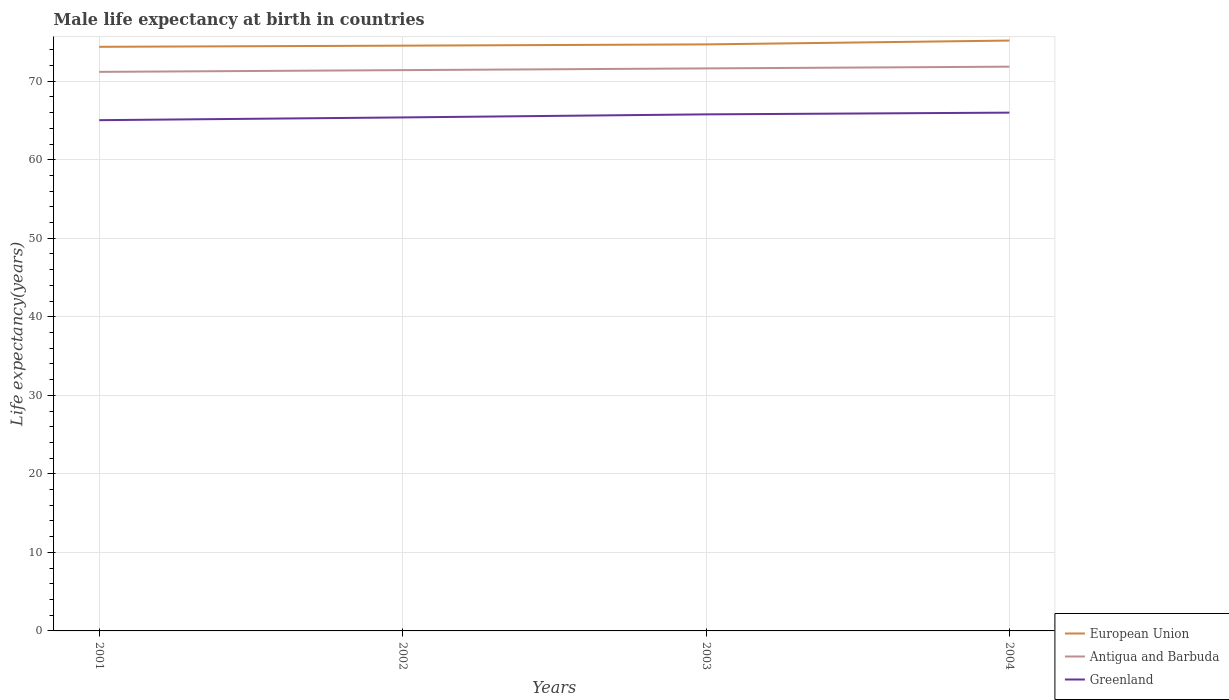How many different coloured lines are there?
Provide a short and direct response. 3. Is the number of lines equal to the number of legend labels?
Ensure brevity in your answer.  Yes. Across all years, what is the maximum male life expectancy at birth in Antigua and Barbuda?
Your answer should be very brief. 71.19. What is the total male life expectancy at birth in Greenland in the graph?
Offer a terse response. -0.96. What is the difference between the highest and the second highest male life expectancy at birth in Antigua and Barbuda?
Keep it short and to the point. 0.66. Is the male life expectancy at birth in European Union strictly greater than the male life expectancy at birth in Greenland over the years?
Your answer should be compact. No. Are the values on the major ticks of Y-axis written in scientific E-notation?
Ensure brevity in your answer.  No. Does the graph contain grids?
Your answer should be compact. Yes. Where does the legend appear in the graph?
Make the answer very short. Bottom right. How many legend labels are there?
Ensure brevity in your answer.  3. What is the title of the graph?
Keep it short and to the point. Male life expectancy at birth in countries. What is the label or title of the Y-axis?
Keep it short and to the point. Life expectancy(years). What is the Life expectancy(years) in European Union in 2001?
Provide a short and direct response. 74.38. What is the Life expectancy(years) of Antigua and Barbuda in 2001?
Ensure brevity in your answer.  71.19. What is the Life expectancy(years) of Greenland in 2001?
Your answer should be very brief. 65.04. What is the Life expectancy(years) of European Union in 2002?
Offer a terse response. 74.53. What is the Life expectancy(years) in Antigua and Barbuda in 2002?
Ensure brevity in your answer.  71.41. What is the Life expectancy(years) in Greenland in 2002?
Give a very brief answer. 65.39. What is the Life expectancy(years) in European Union in 2003?
Make the answer very short. 74.69. What is the Life expectancy(years) of Antigua and Barbuda in 2003?
Give a very brief answer. 71.63. What is the Life expectancy(years) of Greenland in 2003?
Offer a terse response. 65.78. What is the Life expectancy(years) in European Union in 2004?
Your response must be concise. 75.18. What is the Life expectancy(years) in Antigua and Barbuda in 2004?
Provide a succinct answer. 71.85. What is the Life expectancy(years) in Greenland in 2004?
Ensure brevity in your answer.  66. Across all years, what is the maximum Life expectancy(years) of European Union?
Offer a terse response. 75.18. Across all years, what is the maximum Life expectancy(years) in Antigua and Barbuda?
Your answer should be compact. 71.85. Across all years, what is the maximum Life expectancy(years) in Greenland?
Ensure brevity in your answer.  66. Across all years, what is the minimum Life expectancy(years) of European Union?
Your answer should be very brief. 74.38. Across all years, what is the minimum Life expectancy(years) of Antigua and Barbuda?
Your answer should be compact. 71.19. Across all years, what is the minimum Life expectancy(years) in Greenland?
Provide a short and direct response. 65.04. What is the total Life expectancy(years) of European Union in the graph?
Your response must be concise. 298.78. What is the total Life expectancy(years) in Antigua and Barbuda in the graph?
Ensure brevity in your answer.  286.09. What is the total Life expectancy(years) in Greenland in the graph?
Offer a terse response. 262.21. What is the difference between the Life expectancy(years) of European Union in 2001 and that in 2002?
Your response must be concise. -0.15. What is the difference between the Life expectancy(years) of Antigua and Barbuda in 2001 and that in 2002?
Your answer should be very brief. -0.22. What is the difference between the Life expectancy(years) in Greenland in 2001 and that in 2002?
Provide a succinct answer. -0.35. What is the difference between the Life expectancy(years) in European Union in 2001 and that in 2003?
Provide a short and direct response. -0.31. What is the difference between the Life expectancy(years) in Antigua and Barbuda in 2001 and that in 2003?
Your answer should be very brief. -0.44. What is the difference between the Life expectancy(years) in Greenland in 2001 and that in 2003?
Offer a very short reply. -0.74. What is the difference between the Life expectancy(years) in European Union in 2001 and that in 2004?
Your answer should be very brief. -0.8. What is the difference between the Life expectancy(years) of Antigua and Barbuda in 2001 and that in 2004?
Offer a very short reply. -0.66. What is the difference between the Life expectancy(years) of Greenland in 2001 and that in 2004?
Keep it short and to the point. -0.96. What is the difference between the Life expectancy(years) in European Union in 2002 and that in 2003?
Your answer should be compact. -0.16. What is the difference between the Life expectancy(years) in Antigua and Barbuda in 2002 and that in 2003?
Your answer should be very brief. -0.22. What is the difference between the Life expectancy(years) of Greenland in 2002 and that in 2003?
Your answer should be compact. -0.39. What is the difference between the Life expectancy(years) of European Union in 2002 and that in 2004?
Your response must be concise. -0.65. What is the difference between the Life expectancy(years) of Antigua and Barbuda in 2002 and that in 2004?
Offer a very short reply. -0.44. What is the difference between the Life expectancy(years) in Greenland in 2002 and that in 2004?
Give a very brief answer. -0.61. What is the difference between the Life expectancy(years) of European Union in 2003 and that in 2004?
Ensure brevity in your answer.  -0.49. What is the difference between the Life expectancy(years) of Antigua and Barbuda in 2003 and that in 2004?
Offer a very short reply. -0.22. What is the difference between the Life expectancy(years) of Greenland in 2003 and that in 2004?
Your answer should be very brief. -0.22. What is the difference between the Life expectancy(years) in European Union in 2001 and the Life expectancy(years) in Antigua and Barbuda in 2002?
Offer a very short reply. 2.97. What is the difference between the Life expectancy(years) of European Union in 2001 and the Life expectancy(years) of Greenland in 2002?
Your response must be concise. 8.99. What is the difference between the Life expectancy(years) in Antigua and Barbuda in 2001 and the Life expectancy(years) in Greenland in 2002?
Offer a very short reply. 5.8. What is the difference between the Life expectancy(years) in European Union in 2001 and the Life expectancy(years) in Antigua and Barbuda in 2003?
Ensure brevity in your answer.  2.75. What is the difference between the Life expectancy(years) in European Union in 2001 and the Life expectancy(years) in Greenland in 2003?
Offer a very short reply. 8.6. What is the difference between the Life expectancy(years) of Antigua and Barbuda in 2001 and the Life expectancy(years) of Greenland in 2003?
Your response must be concise. 5.41. What is the difference between the Life expectancy(years) in European Union in 2001 and the Life expectancy(years) in Antigua and Barbuda in 2004?
Provide a short and direct response. 2.53. What is the difference between the Life expectancy(years) in European Union in 2001 and the Life expectancy(years) in Greenland in 2004?
Provide a succinct answer. 8.38. What is the difference between the Life expectancy(years) of Antigua and Barbuda in 2001 and the Life expectancy(years) of Greenland in 2004?
Make the answer very short. 5.19. What is the difference between the Life expectancy(years) in European Union in 2002 and the Life expectancy(years) in Antigua and Barbuda in 2003?
Make the answer very short. 2.9. What is the difference between the Life expectancy(years) in European Union in 2002 and the Life expectancy(years) in Greenland in 2003?
Your answer should be very brief. 8.75. What is the difference between the Life expectancy(years) in Antigua and Barbuda in 2002 and the Life expectancy(years) in Greenland in 2003?
Offer a terse response. 5.63. What is the difference between the Life expectancy(years) of European Union in 2002 and the Life expectancy(years) of Antigua and Barbuda in 2004?
Your answer should be very brief. 2.68. What is the difference between the Life expectancy(years) of European Union in 2002 and the Life expectancy(years) of Greenland in 2004?
Make the answer very short. 8.53. What is the difference between the Life expectancy(years) in Antigua and Barbuda in 2002 and the Life expectancy(years) in Greenland in 2004?
Make the answer very short. 5.41. What is the difference between the Life expectancy(years) in European Union in 2003 and the Life expectancy(years) in Antigua and Barbuda in 2004?
Offer a very short reply. 2.84. What is the difference between the Life expectancy(years) in European Union in 2003 and the Life expectancy(years) in Greenland in 2004?
Your answer should be very brief. 8.69. What is the difference between the Life expectancy(years) of Antigua and Barbuda in 2003 and the Life expectancy(years) of Greenland in 2004?
Your answer should be very brief. 5.63. What is the average Life expectancy(years) in European Union per year?
Offer a terse response. 74.7. What is the average Life expectancy(years) of Antigua and Barbuda per year?
Ensure brevity in your answer.  71.52. What is the average Life expectancy(years) of Greenland per year?
Offer a very short reply. 65.55. In the year 2001, what is the difference between the Life expectancy(years) in European Union and Life expectancy(years) in Antigua and Barbuda?
Your answer should be very brief. 3.19. In the year 2001, what is the difference between the Life expectancy(years) in European Union and Life expectancy(years) in Greenland?
Your answer should be very brief. 9.34. In the year 2001, what is the difference between the Life expectancy(years) of Antigua and Barbuda and Life expectancy(years) of Greenland?
Offer a terse response. 6.15. In the year 2002, what is the difference between the Life expectancy(years) of European Union and Life expectancy(years) of Antigua and Barbuda?
Provide a succinct answer. 3.12. In the year 2002, what is the difference between the Life expectancy(years) of European Union and Life expectancy(years) of Greenland?
Your answer should be very brief. 9.14. In the year 2002, what is the difference between the Life expectancy(years) in Antigua and Barbuda and Life expectancy(years) in Greenland?
Your answer should be very brief. 6.02. In the year 2003, what is the difference between the Life expectancy(years) in European Union and Life expectancy(years) in Antigua and Barbuda?
Give a very brief answer. 3.06. In the year 2003, what is the difference between the Life expectancy(years) in European Union and Life expectancy(years) in Greenland?
Offer a very short reply. 8.91. In the year 2003, what is the difference between the Life expectancy(years) of Antigua and Barbuda and Life expectancy(years) of Greenland?
Provide a short and direct response. 5.85. In the year 2004, what is the difference between the Life expectancy(years) of European Union and Life expectancy(years) of Antigua and Barbuda?
Ensure brevity in your answer.  3.33. In the year 2004, what is the difference between the Life expectancy(years) of European Union and Life expectancy(years) of Greenland?
Your answer should be very brief. 9.18. In the year 2004, what is the difference between the Life expectancy(years) of Antigua and Barbuda and Life expectancy(years) of Greenland?
Keep it short and to the point. 5.85. What is the ratio of the Life expectancy(years) in Antigua and Barbuda in 2001 to that in 2002?
Provide a succinct answer. 1. What is the ratio of the Life expectancy(years) in Greenland in 2001 to that in 2002?
Your response must be concise. 0.99. What is the ratio of the Life expectancy(years) in Greenland in 2001 to that in 2003?
Your response must be concise. 0.99. What is the ratio of the Life expectancy(years) in Antigua and Barbuda in 2001 to that in 2004?
Your response must be concise. 0.99. What is the ratio of the Life expectancy(years) in Greenland in 2001 to that in 2004?
Offer a terse response. 0.99. What is the ratio of the Life expectancy(years) of European Union in 2002 to that in 2003?
Provide a short and direct response. 1. What is the ratio of the Life expectancy(years) of Antigua and Barbuda in 2002 to that in 2003?
Ensure brevity in your answer.  1. What is the ratio of the Life expectancy(years) of Greenland in 2002 to that in 2003?
Make the answer very short. 0.99. What is the ratio of the Life expectancy(years) in Antigua and Barbuda in 2002 to that in 2004?
Keep it short and to the point. 0.99. What is the difference between the highest and the second highest Life expectancy(years) of European Union?
Make the answer very short. 0.49. What is the difference between the highest and the second highest Life expectancy(years) in Antigua and Barbuda?
Offer a terse response. 0.22. What is the difference between the highest and the second highest Life expectancy(years) of Greenland?
Your answer should be compact. 0.22. What is the difference between the highest and the lowest Life expectancy(years) of European Union?
Provide a short and direct response. 0.8. What is the difference between the highest and the lowest Life expectancy(years) in Antigua and Barbuda?
Your answer should be very brief. 0.66. 